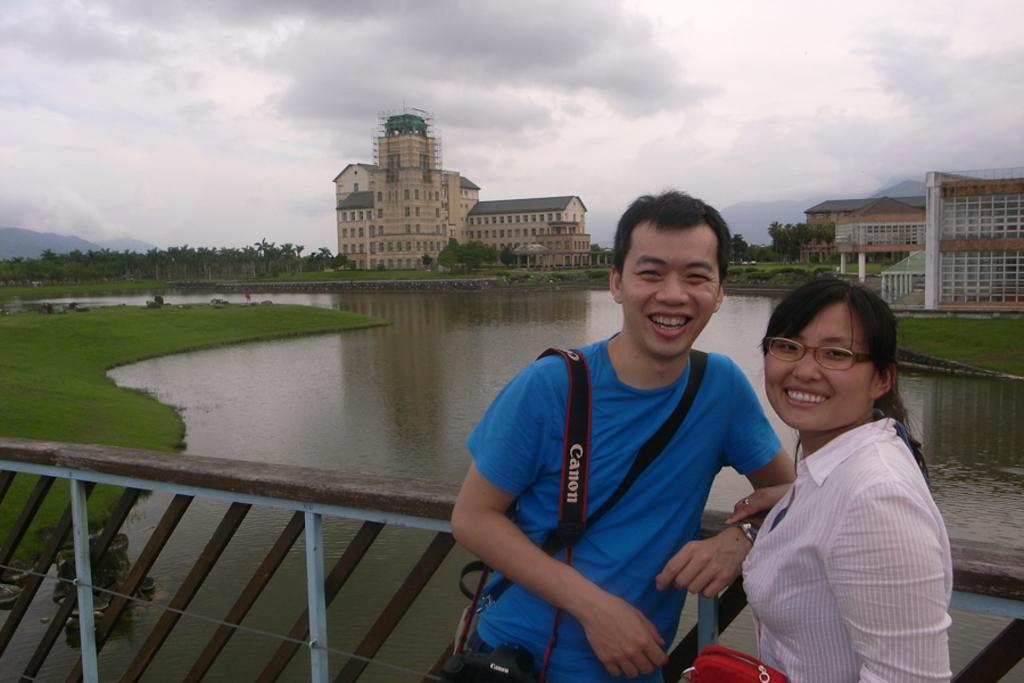<image>
Summarize the visual content of the image. A young man with a Canon camera and his female companion lean against a dam bridge smiling for the camera. 